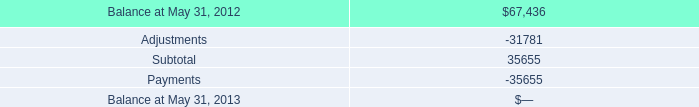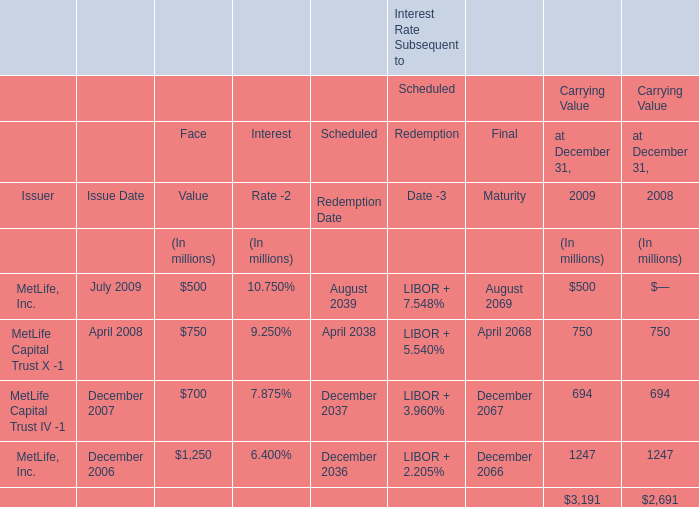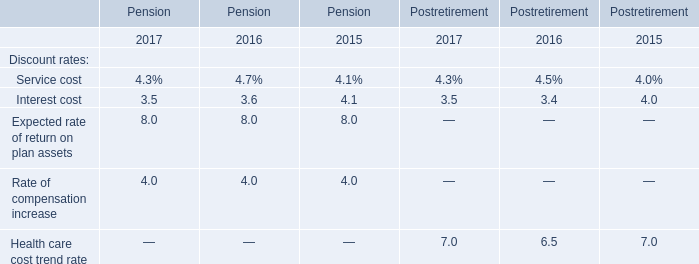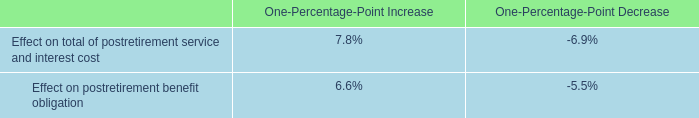what's the total amount of Balance at May 31, 2012, and MetLife, Inc. of Interest Rate Subsequent to Final Maturity is ? 
Computations: (67436.0 + 2069.0)
Answer: 69505.0. 